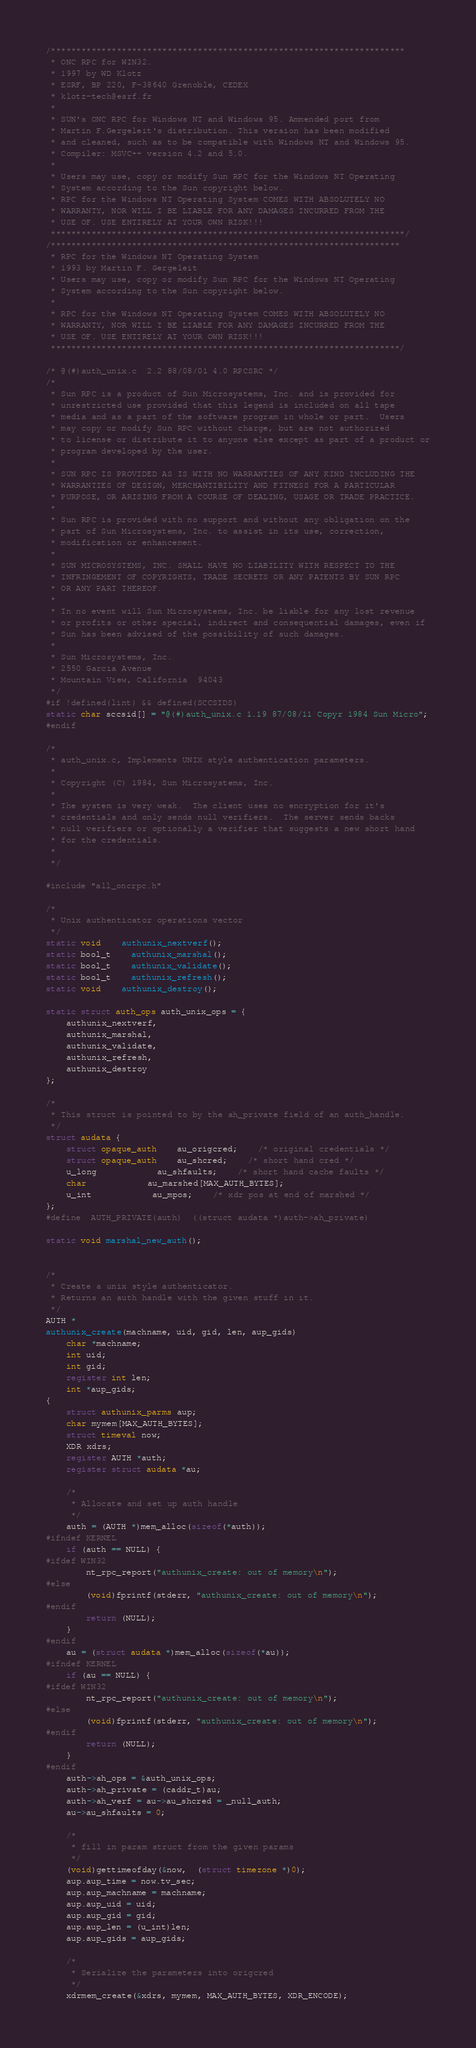Convert code to text. <code><loc_0><loc_0><loc_500><loc_500><_C_>/**********************************************************************
 * ONC RPC for WIN32.
 * 1997 by WD Klotz
 * ESRF, BP 220, F-38640 Grenoble, CEDEX
 * klotz-tech@esrf.fr
 *
 * SUN's ONC RPC for Windows NT and Windows 95. Ammended port from
 * Martin F.Gergeleit's distribution. This version has been modified
 * and cleaned, such as to be compatible with Windows NT and Windows 95. 
 * Compiler: MSVC++ version 4.2 and 5.0.
 *
 * Users may use, copy or modify Sun RPC for the Windows NT Operating 
 * System according to the Sun copyright below.
 * RPC for the Windows NT Operating System COMES WITH ABSOLUTELY NO 
 * WARRANTY, NOR WILL I BE LIABLE FOR ANY DAMAGES INCURRED FROM THE 
 * USE OF. USE ENTIRELY AT YOUR OWN RISK!!!
 **********************************************************************/
/*********************************************************************
 * RPC for the Windows NT Operating System
 * 1993 by Martin F. Gergeleit
 * Users may use, copy or modify Sun RPC for the Windows NT Operating 
 * System according to the Sun copyright below.
 *
 * RPC for the Windows NT Operating System COMES WITH ABSOLUTELY NO 
 * WARRANTY, NOR WILL I BE LIABLE FOR ANY DAMAGES INCURRED FROM THE 
 * USE OF. USE ENTIRELY AT YOUR OWN RISK!!!
 *********************************************************************/

/* @(#)auth_unix.c	2.2 88/08/01 4.0 RPCSRC */
/*
 * Sun RPC is a product of Sun Microsystems, Inc. and is provided for
 * unrestricted use provided that this legend is included on all tape
 * media and as a part of the software program in whole or part.  Users
 * may copy or modify Sun RPC without charge, but are not authorized
 * to license or distribute it to anyone else except as part of a product or
 * program developed by the user.
 *
 * SUN RPC IS PROVIDED AS IS WITH NO WARRANTIES OF ANY KIND INCLUDING THE
 * WARRANTIES OF DESIGN, MERCHANTIBILITY AND FITNESS FOR A PARTICULAR
 * PURPOSE, OR ARISING FROM A COURSE OF DEALING, USAGE OR TRADE PRACTICE.
 *
 * Sun RPC is provided with no support and without any obligation on the
 * part of Sun Microsystems, Inc. to assist in its use, correction,
 * modification or enhancement.
 *
 * SUN MICROSYSTEMS, INC. SHALL HAVE NO LIABILITY WITH RESPECT TO THE
 * INFRINGEMENT OF COPYRIGHTS, TRADE SECRETS OR ANY PATENTS BY SUN RPC
 * OR ANY PART THEREOF.
 *
 * In no event will Sun Microsystems, Inc. be liable for any lost revenue
 * or profits or other special, indirect and consequential damages, even if
 * Sun has been advised of the possibility of such damages.
 *
 * Sun Microsystems, Inc.
 * 2550 Garcia Avenue
 * Mountain View, California  94043
 */
#if !defined(lint) && defined(SCCSIDS)
static char sccsid[] = "@(#)auth_unix.c 1.19 87/08/11 Copyr 1984 Sun Micro";
#endif

/*
 * auth_unix.c, Implements UNIX style authentication parameters.
 *
 * Copyright (C) 1984, Sun Microsystems, Inc.
 *
 * The system is very weak.  The client uses no encryption for it's
 * credentials and only sends null verifiers.  The server sends backs
 * null verifiers or optionally a verifier that suggests a new short hand
 * for the credentials.
 *
 */

#include "all_oncrpc.h"

/*
 * Unix authenticator operations vector
 */
static void	authunix_nextverf();
static bool_t	authunix_marshal();
static bool_t	authunix_validate();
static bool_t	authunix_refresh();
static void	authunix_destroy();

static struct auth_ops auth_unix_ops = {
	authunix_nextverf,
	authunix_marshal,
	authunix_validate,
	authunix_refresh,
	authunix_destroy
};

/*
 * This struct is pointed to by the ah_private field of an auth_handle.
 */
struct audata {
	struct opaque_auth	au_origcred;	/* original credentials */
	struct opaque_auth	au_shcred;	/* short hand cred */
	u_long			au_shfaults;	/* short hand cache faults */
	char			au_marshed[MAX_AUTH_BYTES];
	u_int			au_mpos;	/* xdr pos at end of marshed */
};
#define	AUTH_PRIVATE(auth)	((struct audata *)auth->ah_private)

static void marshal_new_auth();


/*
 * Create a unix style authenticator.
 * Returns an auth handle with the given stuff in it.
 */
AUTH *
authunix_create(machname, uid, gid, len, aup_gids)
	char *machname;
	int uid;
	int gid;
	register int len;
	int *aup_gids;
{
	struct authunix_parms aup;
	char mymem[MAX_AUTH_BYTES];
	struct timeval now;
	XDR xdrs;
	register AUTH *auth;
	register struct audata *au;

	/*
	 * Allocate and set up auth handle
	 */
	auth = (AUTH *)mem_alloc(sizeof(*auth));
#ifndef KERNEL
	if (auth == NULL) {
#ifdef WIN32
		nt_rpc_report("authunix_create: out of memory\n");
#else
		(void)fprintf(stderr, "authunix_create: out of memory\n");
#endif
		return (NULL);
	}
#endif
	au = (struct audata *)mem_alloc(sizeof(*au));
#ifndef KERNEL
	if (au == NULL) {
#ifdef WIN32
		nt_rpc_report("authunix_create: out of memory\n");
#else
		(void)fprintf(stderr, "authunix_create: out of memory\n");
#endif
		return (NULL);
	}
#endif
	auth->ah_ops = &auth_unix_ops;
	auth->ah_private = (caddr_t)au;
	auth->ah_verf = au->au_shcred = _null_auth;
	au->au_shfaults = 0;

	/*
	 * fill in param struct from the given params
	 */
	(void)gettimeofday(&now,  (struct timezone *)0);
	aup.aup_time = now.tv_sec;
	aup.aup_machname = machname;
	aup.aup_uid = uid;
	aup.aup_gid = gid;
	aup.aup_len = (u_int)len;
	aup.aup_gids = aup_gids;

	/*
	 * Serialize the parameters into origcred
	 */
	xdrmem_create(&xdrs, mymem, MAX_AUTH_BYTES, XDR_ENCODE);</code> 